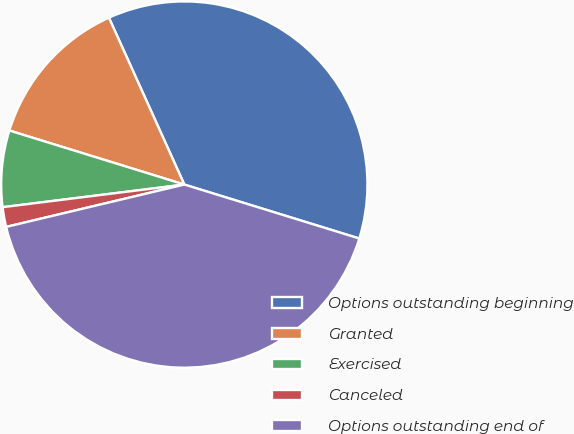Convert chart to OTSL. <chart><loc_0><loc_0><loc_500><loc_500><pie_chart><fcel>Options outstanding beginning<fcel>Granted<fcel>Exercised<fcel>Canceled<fcel>Options outstanding end of<nl><fcel>36.52%<fcel>13.48%<fcel>6.74%<fcel>1.74%<fcel>41.53%<nl></chart> 